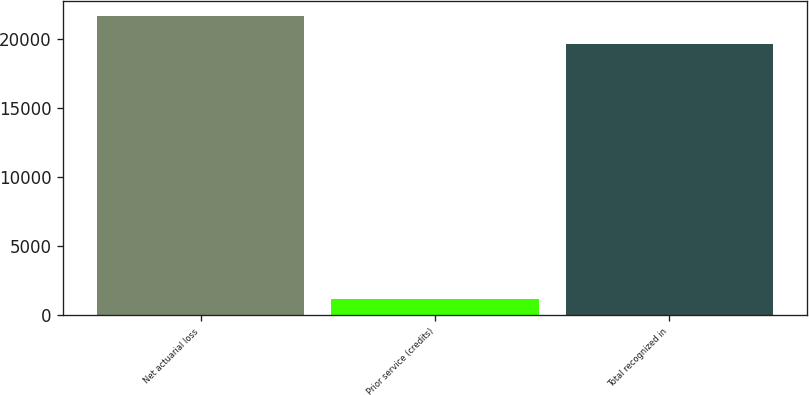Convert chart to OTSL. <chart><loc_0><loc_0><loc_500><loc_500><bar_chart><fcel>Net actuarial loss<fcel>Prior service (credits)<fcel>Total recognized in<nl><fcel>21643.6<fcel>1195<fcel>19676<nl></chart> 